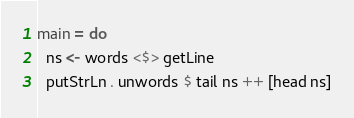Convert code to text. <code><loc_0><loc_0><loc_500><loc_500><_Haskell_>main = do
  ns <- words <$> getLine
  putStrLn . unwords $ tail ns ++ [head ns]</code> 